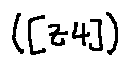Convert formula to latex. <formula><loc_0><loc_0><loc_500><loc_500>( [ z 4 ] )</formula> 